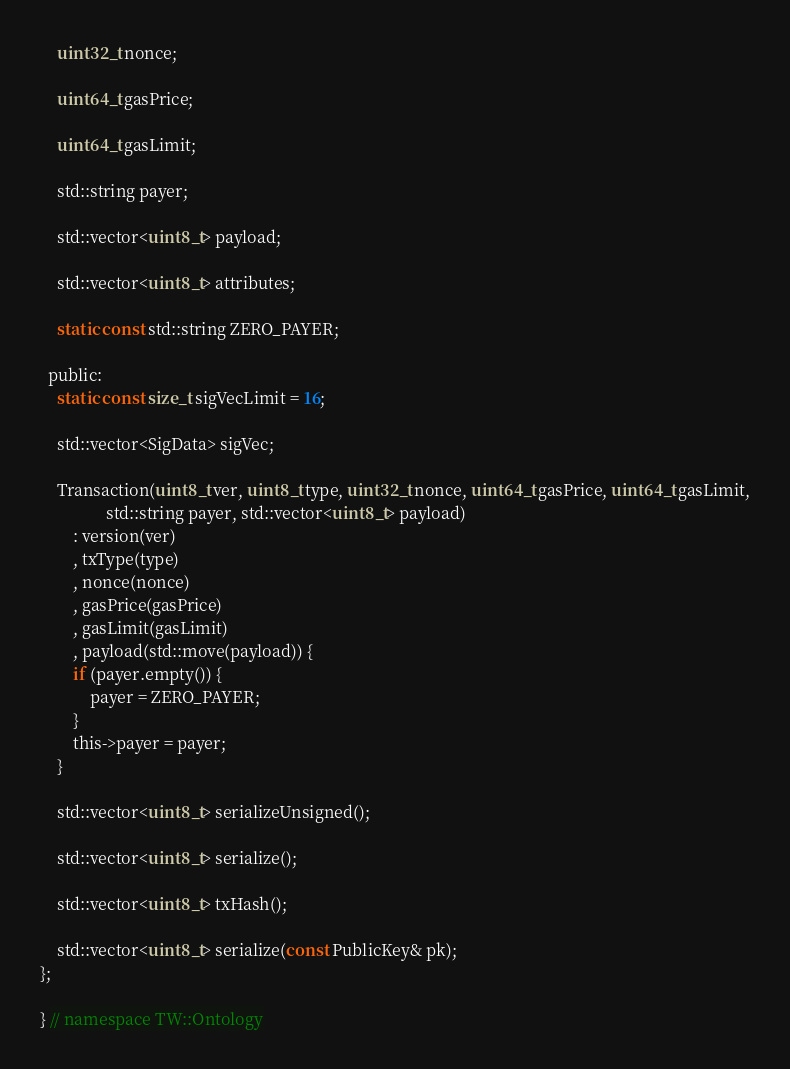<code> <loc_0><loc_0><loc_500><loc_500><_C_>    uint32_t nonce;

    uint64_t gasPrice;

    uint64_t gasLimit;

    std::string payer;

    std::vector<uint8_t> payload;

    std::vector<uint8_t> attributes;

    static const std::string ZERO_PAYER;

  public:
    static const size_t sigVecLimit = 16;

    std::vector<SigData> sigVec;

    Transaction(uint8_t ver, uint8_t type, uint32_t nonce, uint64_t gasPrice, uint64_t gasLimit,
                std::string payer, std::vector<uint8_t> payload)
        : version(ver)
        , txType(type)
        , nonce(nonce)
        , gasPrice(gasPrice)
        , gasLimit(gasLimit)
        , payload(std::move(payload)) {
        if (payer.empty()) {
            payer = ZERO_PAYER;
        }
        this->payer = payer;
    }

    std::vector<uint8_t> serializeUnsigned();

    std::vector<uint8_t> serialize();

    std::vector<uint8_t> txHash();

    std::vector<uint8_t> serialize(const PublicKey& pk);
};

} // namespace TW::Ontology</code> 